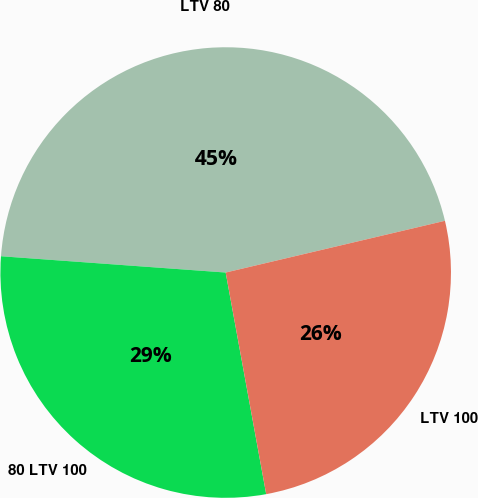<chart> <loc_0><loc_0><loc_500><loc_500><pie_chart><fcel>LTV 80<fcel>80 LTV 100<fcel>LTV 100<nl><fcel>45.16%<fcel>29.03%<fcel>25.81%<nl></chart> 